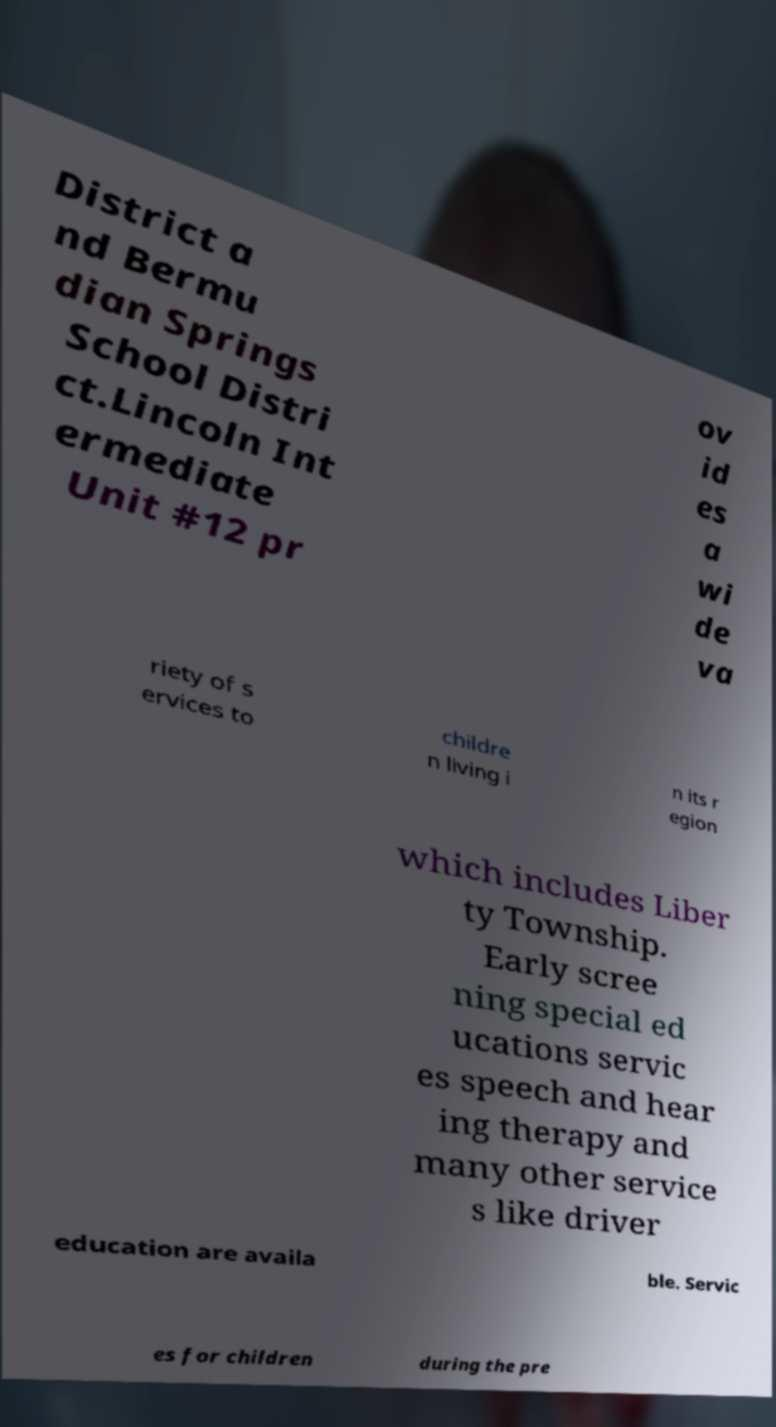Can you read and provide the text displayed in the image?This photo seems to have some interesting text. Can you extract and type it out for me? District a nd Bermu dian Springs School Distri ct.Lincoln Int ermediate Unit #12 pr ov id es a wi de va riety of s ervices to childre n living i n its r egion which includes Liber ty Township. Early scree ning special ed ucations servic es speech and hear ing therapy and many other service s like driver education are availa ble. Servic es for children during the pre 